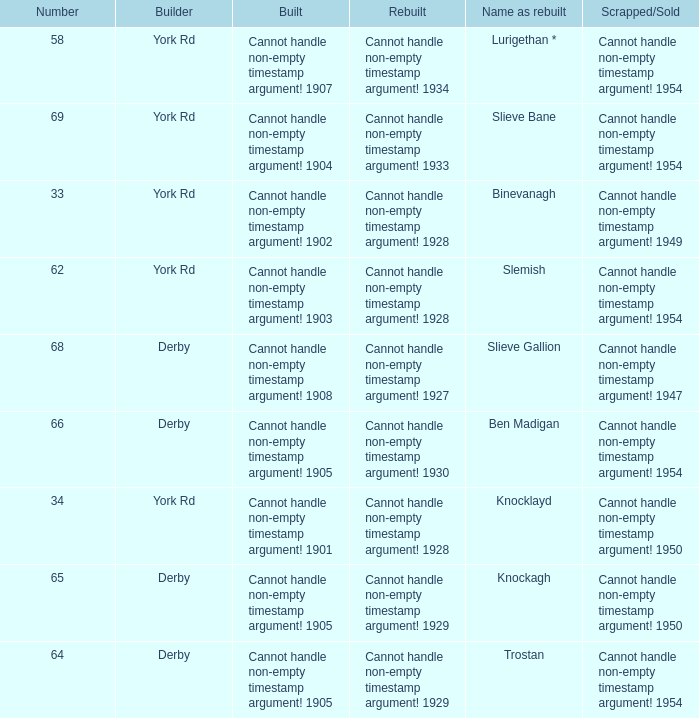Which Rebuilt has a Builder of derby, and a Name as rebuilt of ben madigan? Cannot handle non-empty timestamp argument! 1930. 